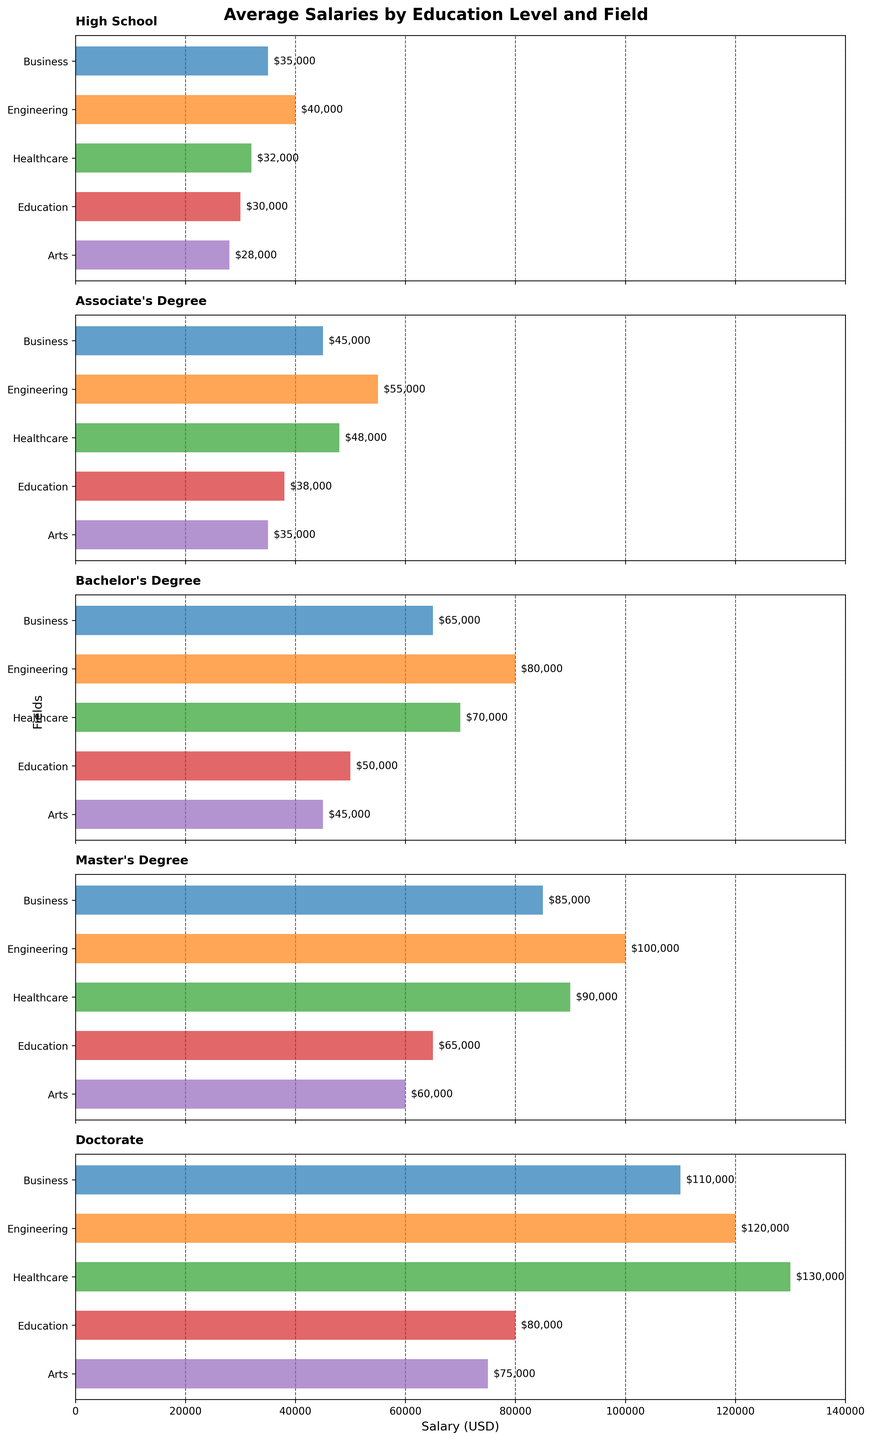What is the title of the figure? The title of a figure is typically located at the top and provides a summary of what the figure represents. In this case, look at the top of the figure.
Answer: Average Salaries by Education Level and Field How many educational levels are compared in the figure? Count the number of horizontal subplots in the figure since each subplot represents a different education level.
Answer: 5 Which field has the highest average salary for those with a Bachelor's Degree? Locate the subplot titled "Bachelor's Degree" and compare the heights of the bars within this subplot. The highest bar represents the highest average salary.
Answer: Engineering What is the average salary difference between a Master's Degree and a High School diploma in the Healthcare field? Find the salaries for the Healthcare field in the subplots titled "Master's Degree" and "High School." Subtract the High School salary from the Master's Degree salary.
Answer: $58,000 Which educational level shows the smallest difference in average salaries between the Business and Arts fields? Calculate the difference in average salaries between the Business and Arts fields for each educational level. Identify the smallest difference among these values.
Answer: High School In how many fields do individuals with a Doctorate earn more than $100,000? Refer to the subplot titled "Doctorate." Count the bars that represent an average salary greater than $100,000.
Answer: 3 Which field shows the largest increase in average salary from a High School diploma to a Bachelor's Degree? Calculate the increase in average salary for each field by subtracting the High School salary from the Bachelor's Degree salary. Identify the field with the largest increase.
Answer: Engineering What is the average salary difference across all fields for an Associate's Degree versus a Bachelor's Degree? Subtract the salary for an Associate's Degree from the salary for a Bachelor's Degree for each field and then average these differences.
Answer: $20,000 How many fields have higher average salaries with a Bachelor's Degree compared to a Master's Degree in Business? Compare the salaries in each field for a Bachelor's Degree and a Master's Degree. Count how many fields have a lower salary for a Master's Degree than a Bachelor's Degree in the Business field.
Answer: 0 Which educational level has the widest range of average salaries across different fields? For each educational level, calculate the range by subtracting the lowest salary from the highest salary. Compare these ranges to identify the widest one.
Answer: Doctorate 